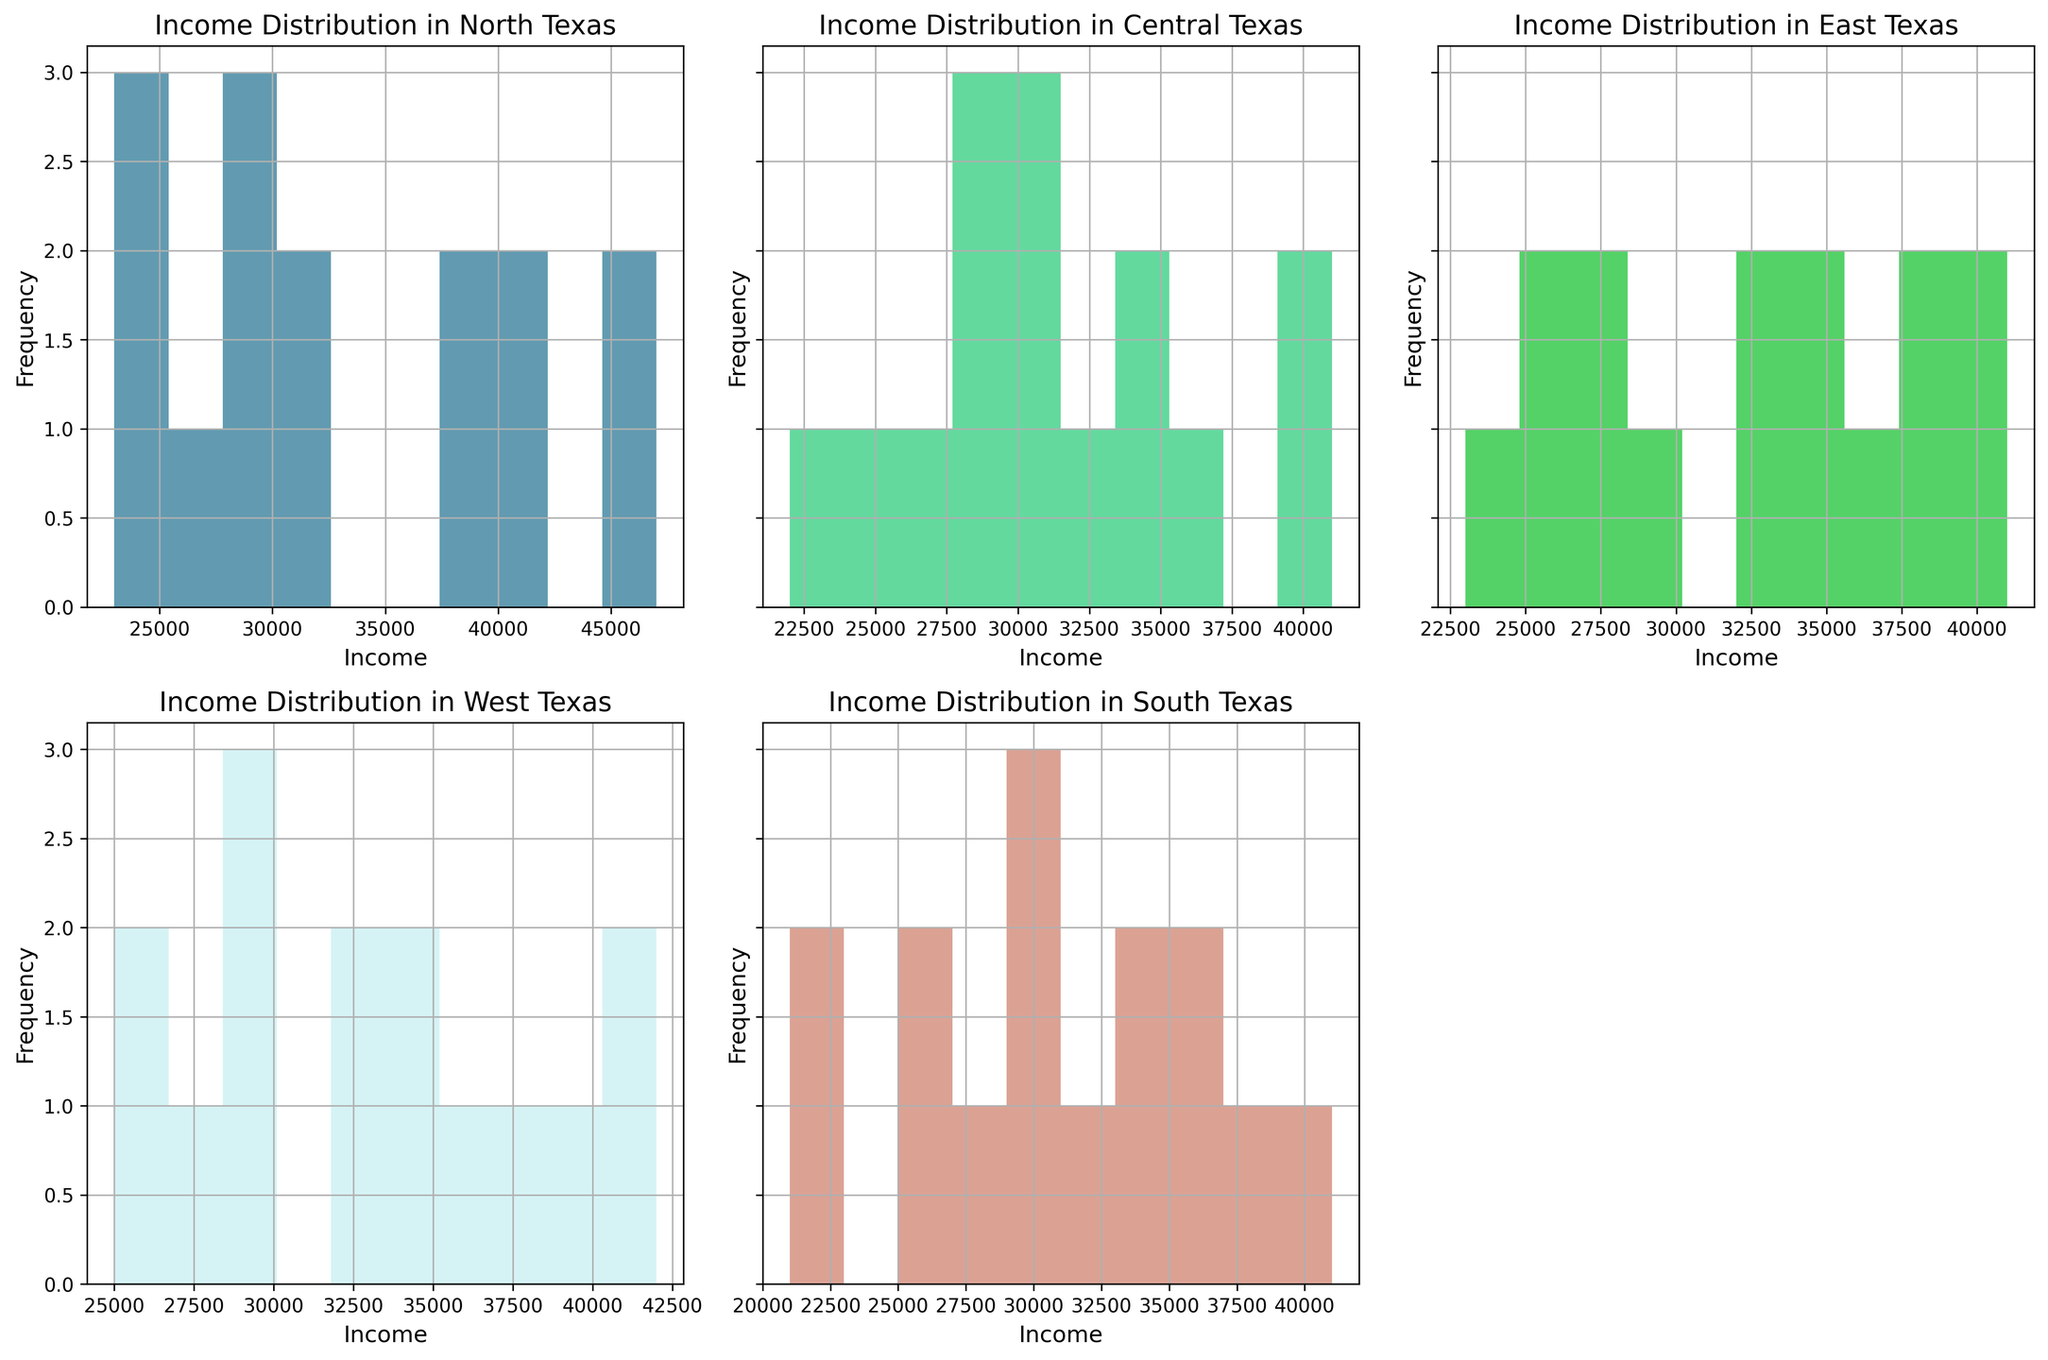Which region has the highest peak in the histogram? By observing the histograms, the histogram with the highest peak will have the tallest bar. Look for the tallest bar among all histograms across different regions.
Answer: Central Texas Which income range has the highest frequency in North Texas? Check the tallest bar in the histogram for North Texas and note the income range it represents.
Answer: 25000-30000 How do the income distributions in North Texas and South Texas compare visually? Compare the shapes and heights of the histograms for North Texas and South Texas to see if there are similarities or differences in their distributions.
Answer: North Texas has a peak at lower incomes while South Texas has a more even distribution What is the common income range with the highest frequency across all regions? Evaluate the highest bars across the histograms to identify if there's an income range that appears frequently as the highest in multiple regions.
Answer: 25000-30000 Which region has the most diverse income distribution? A diverse income distribution would be represented by a histogram with more evenly spread out bars rather than one with a peak. Identify the histogram where no single bar stands out significantly.
Answer: South Texas Is there any region where the income distribution shows two distinct peaks? Look for any histograms with two high bars separated by lower bars, indicating two distinct income peaks.
Answer: West Texas What is the range of incomes shown in the histogram for Central Texas? Identify the lowest and highest income values represented by the bars in the Central Texas histogram.
Answer: 21000 to 41000 Do East Texas and West Texas have similar income distributions? Compare the histograms of East Texas and West Texas to evaluate if their income distributions are similarly shaped and positioned.
Answer: Yes, they have similar shapes with peaks around the same income ranges Which region is the least likely to have families with income less than $25,000? Find the histogram with the lowest or no bars in the income range less than $25,000.
Answer: West Texas What is the overall pattern you observe across all regions? Summarize the general trend seen across all histograms, such as common income ranges and the overall shape of distributions.
Answer: Most regions have peaks around 25,000-30,000, with some variation in higher incomes 